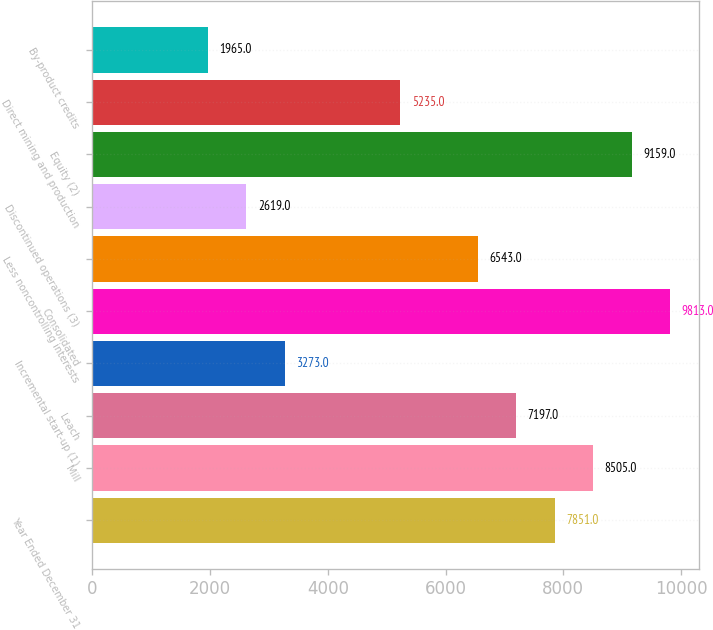Convert chart to OTSL. <chart><loc_0><loc_0><loc_500><loc_500><bar_chart><fcel>Year Ended December 31<fcel>Mill<fcel>Leach<fcel>Incremental start-up (1)<fcel>Consolidated<fcel>Less noncontrolling interests<fcel>Discontinued operations (3)<fcel>Equity (2)<fcel>Direct mining and production<fcel>By-product credits<nl><fcel>7851<fcel>8505<fcel>7197<fcel>3273<fcel>9813<fcel>6543<fcel>2619<fcel>9159<fcel>5235<fcel>1965<nl></chart> 